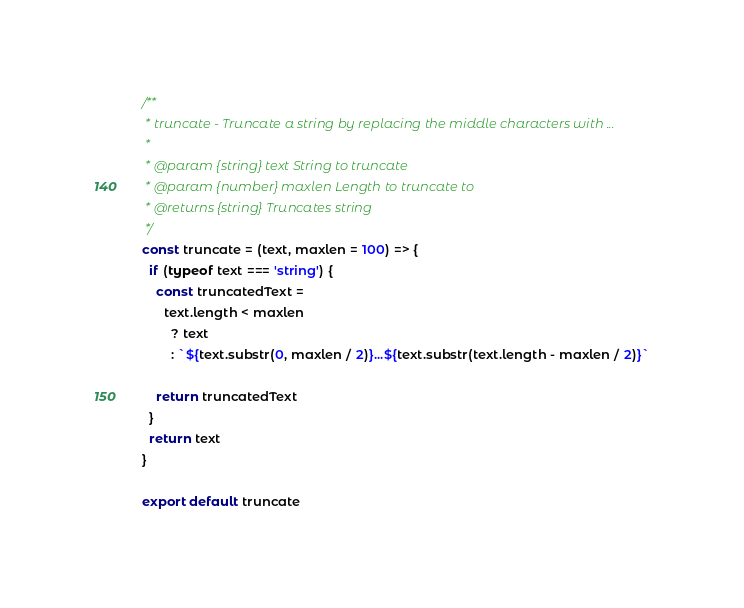<code> <loc_0><loc_0><loc_500><loc_500><_JavaScript_>/**
 * truncate - Truncate a string by replacing the middle characters with ...
 *
 * @param {string} text String to truncate
 * @param {number} maxlen Length to truncate to
 * @returns {string} Truncates string
 */
const truncate = (text, maxlen = 100) => {
  if (typeof text === 'string') {
    const truncatedText =
      text.length < maxlen
        ? text
        : `${text.substr(0, maxlen / 2)}...${text.substr(text.length - maxlen / 2)}`

    return truncatedText
  }
  return text
}

export default truncate
</code> 